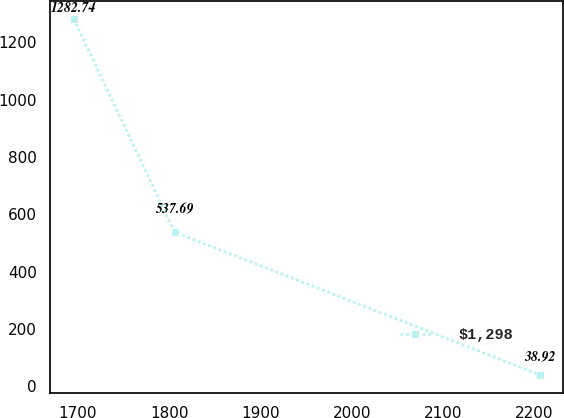Convert chart to OTSL. <chart><loc_0><loc_0><loc_500><loc_500><line_chart><ecel><fcel>$1,298<nl><fcel>1695.23<fcel>1282.74<nl><fcel>1805.83<fcel>537.69<nl><fcel>2206.24<fcel>38.92<nl></chart> 